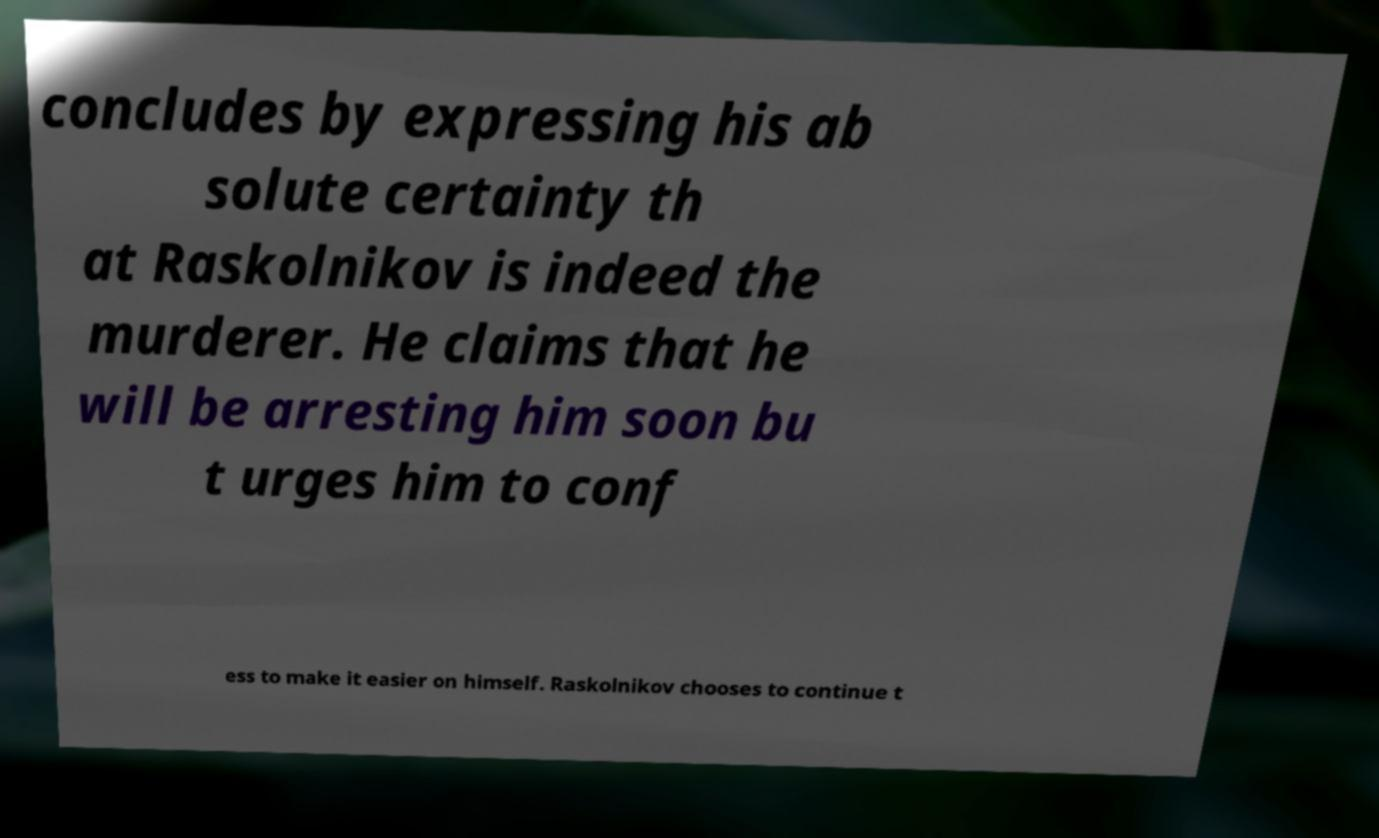Can you read and provide the text displayed in the image?This photo seems to have some interesting text. Can you extract and type it out for me? concludes by expressing his ab solute certainty th at Raskolnikov is indeed the murderer. He claims that he will be arresting him soon bu t urges him to conf ess to make it easier on himself. Raskolnikov chooses to continue t 